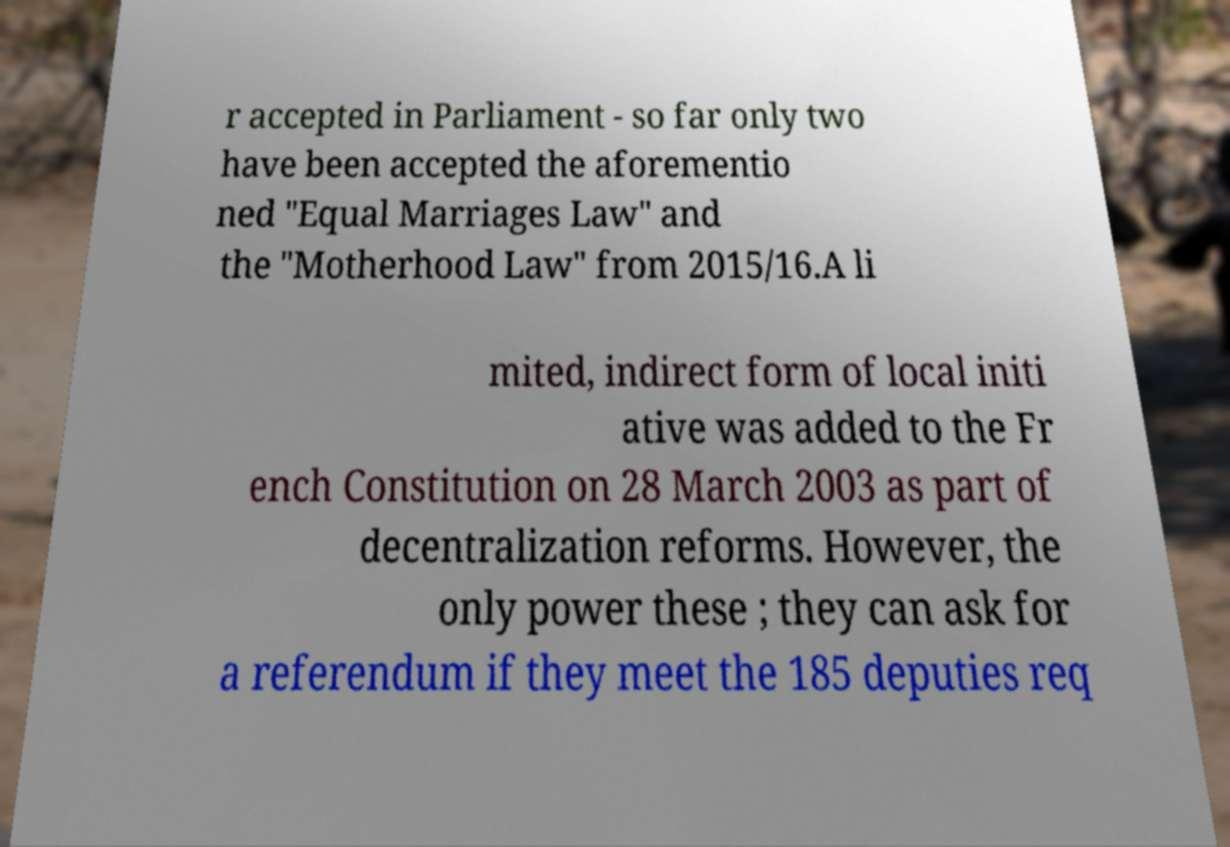Could you extract and type out the text from this image? r accepted in Parliament - so far only two have been accepted the aforementio ned "Equal Marriages Law" and the "Motherhood Law" from 2015/16.A li mited, indirect form of local initi ative was added to the Fr ench Constitution on 28 March 2003 as part of decentralization reforms. However, the only power these ; they can ask for a referendum if they meet the 185 deputies req 